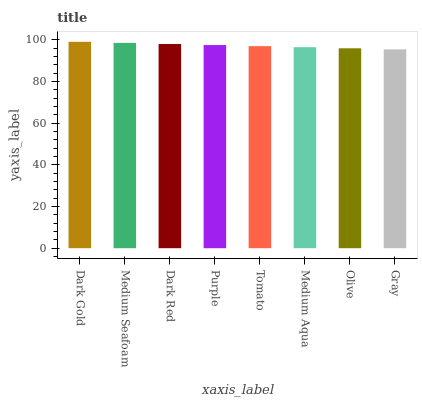Is Gray the minimum?
Answer yes or no. Yes. Is Dark Gold the maximum?
Answer yes or no. Yes. Is Medium Seafoam the minimum?
Answer yes or no. No. Is Medium Seafoam the maximum?
Answer yes or no. No. Is Dark Gold greater than Medium Seafoam?
Answer yes or no. Yes. Is Medium Seafoam less than Dark Gold?
Answer yes or no. Yes. Is Medium Seafoam greater than Dark Gold?
Answer yes or no. No. Is Dark Gold less than Medium Seafoam?
Answer yes or no. No. Is Purple the high median?
Answer yes or no. Yes. Is Tomato the low median?
Answer yes or no. Yes. Is Dark Gold the high median?
Answer yes or no. No. Is Medium Aqua the low median?
Answer yes or no. No. 